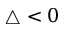<formula> <loc_0><loc_0><loc_500><loc_500>\triangle < 0</formula> 